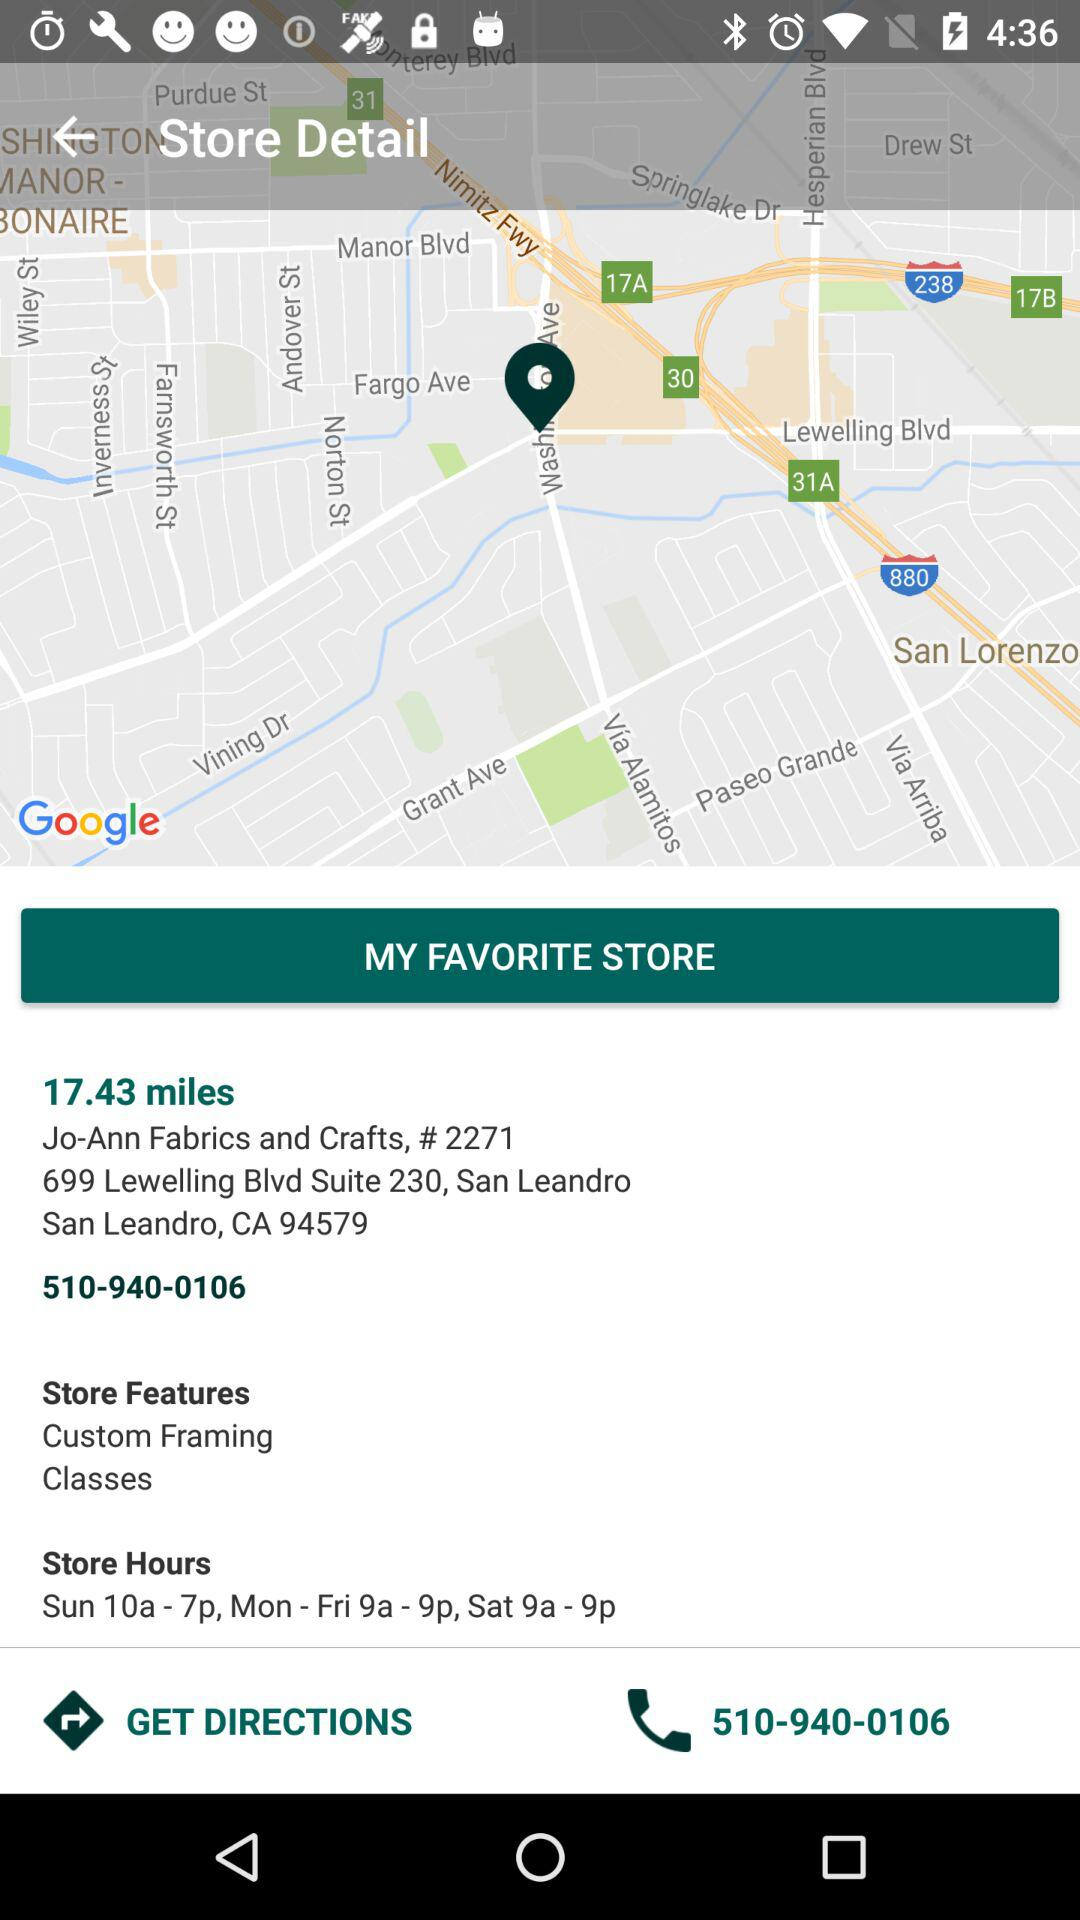What are the store hours?
Answer the question using a single word or phrase. Sun 10a - 7p, Mon - Fri 9a - 9p, Sat 9a - 9p 